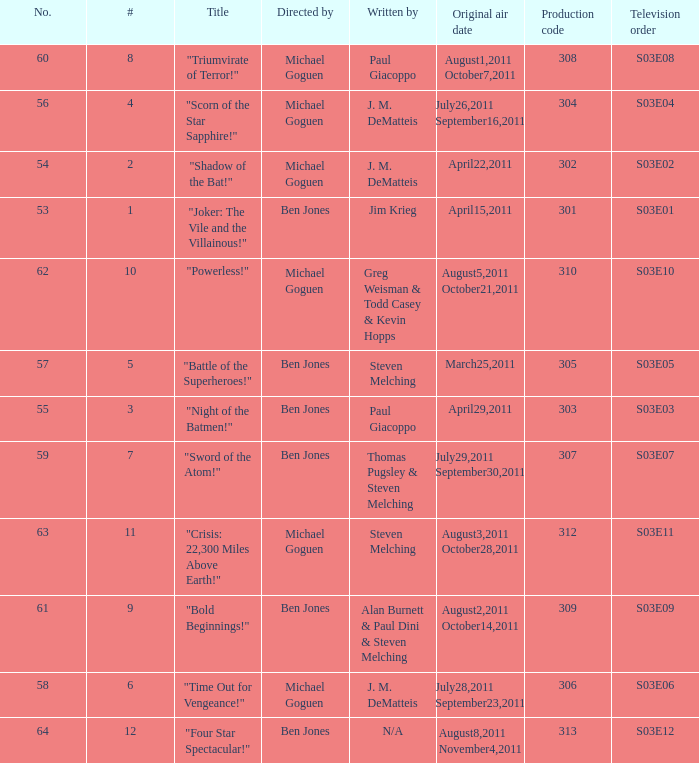What is the original air date of the episode directed by ben jones and written by steven melching?  March25,2011. 